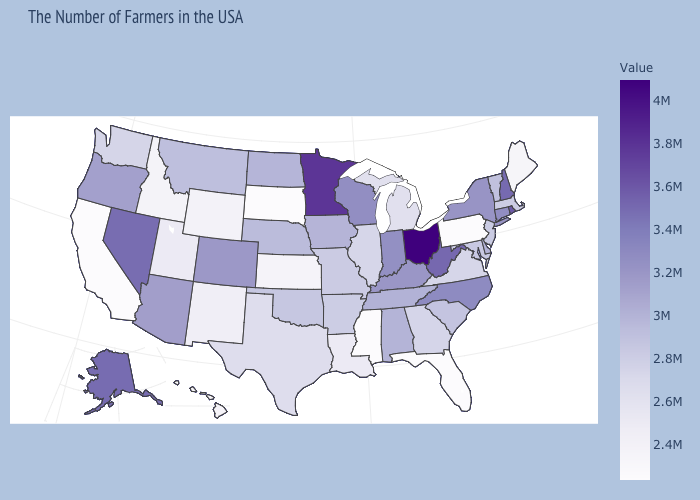Among the states that border Kentucky , does Ohio have the highest value?
Be succinct. Yes. Does the map have missing data?
Give a very brief answer. No. Which states have the lowest value in the Northeast?
Write a very short answer. Pennsylvania. Among the states that border Kansas , which have the lowest value?
Be succinct. Missouri. Among the states that border South Dakota , does Wyoming have the lowest value?
Keep it brief. Yes. Which states hav the highest value in the South?
Write a very short answer. West Virginia. Among the states that border Montana , does North Dakota have the lowest value?
Give a very brief answer. No. Among the states that border New Jersey , which have the highest value?
Keep it brief. New York. 